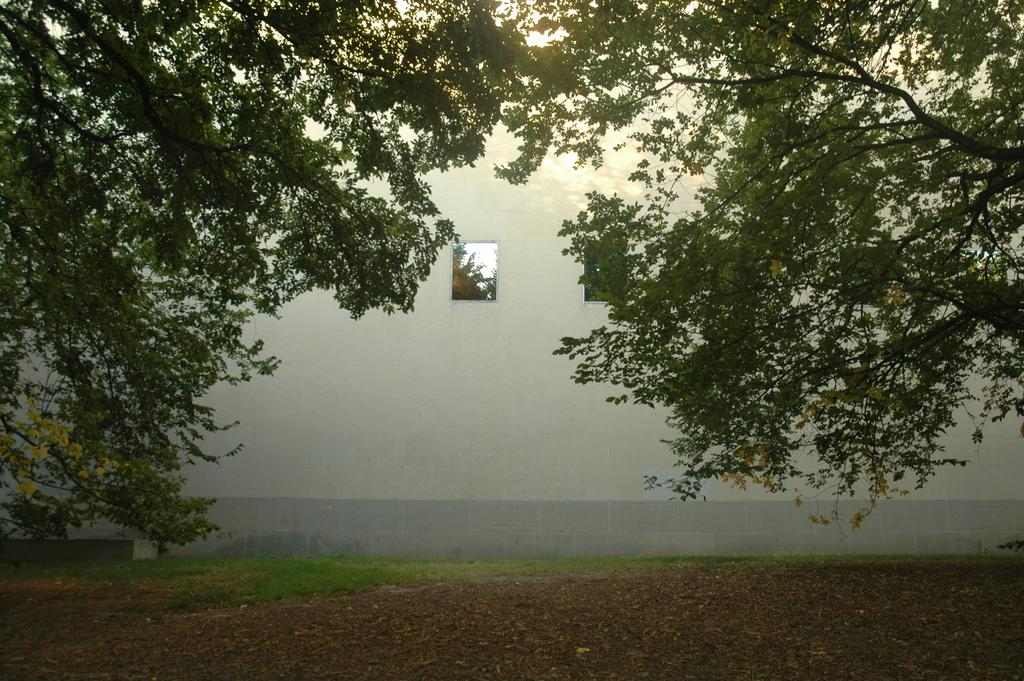What type of vegetation can be seen in the image? There are trees in the image. What can be seen on the ground in the image? The ground is visible in the image. What type of plant life is present on the ground? There is grass in the image. What structures are visible in the image? There is a wall and a window in the image. What can be seen through the window? Leaves and the sky are visible through the window. What type of paint is used on the toys in the image? There are no toys present in the image, so it is not possible to determine the type of paint used on them. What emotion can be seen on the faces of the people in the image? There are no people present in the image, so it is not possible to determine their emotions. 